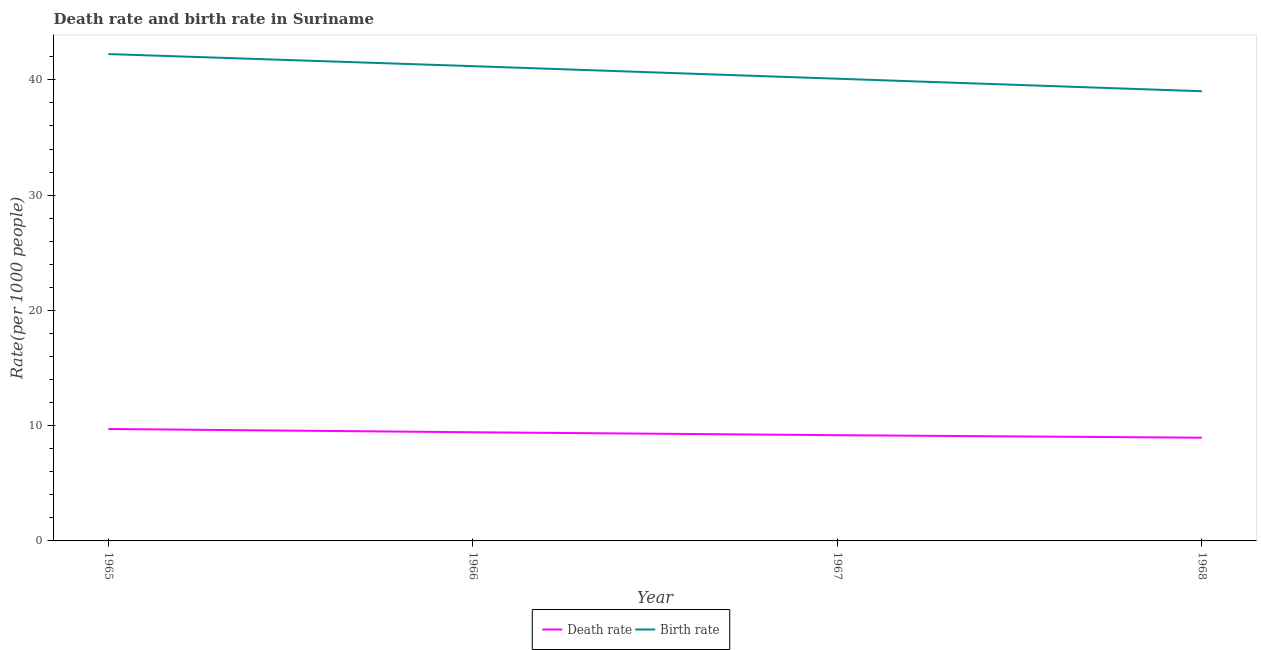How many different coloured lines are there?
Make the answer very short. 2. Does the line corresponding to birth rate intersect with the line corresponding to death rate?
Make the answer very short. No. Is the number of lines equal to the number of legend labels?
Provide a succinct answer. Yes. What is the birth rate in 1967?
Offer a terse response. 40.1. Across all years, what is the maximum death rate?
Your answer should be compact. 9.71. Across all years, what is the minimum birth rate?
Provide a succinct answer. 39.01. In which year was the birth rate maximum?
Offer a terse response. 1965. In which year was the birth rate minimum?
Give a very brief answer. 1968. What is the total death rate in the graph?
Offer a very short reply. 37.27. What is the difference between the death rate in 1965 and that in 1968?
Offer a very short reply. 0.76. What is the difference between the birth rate in 1966 and the death rate in 1965?
Give a very brief answer. 31.48. What is the average birth rate per year?
Your response must be concise. 40.64. In the year 1968, what is the difference between the birth rate and death rate?
Make the answer very short. 30.06. In how many years, is the death rate greater than 26?
Provide a short and direct response. 0. What is the ratio of the death rate in 1967 to that in 1968?
Keep it short and to the point. 1.02. Is the birth rate in 1965 less than that in 1967?
Offer a very short reply. No. What is the difference between the highest and the second highest birth rate?
Your answer should be very brief. 1.05. What is the difference between the highest and the lowest death rate?
Ensure brevity in your answer.  0.76. Is the birth rate strictly less than the death rate over the years?
Your response must be concise. No. Does the graph contain grids?
Your answer should be compact. No. How many legend labels are there?
Your response must be concise. 2. How are the legend labels stacked?
Your response must be concise. Horizontal. What is the title of the graph?
Give a very brief answer. Death rate and birth rate in Suriname. What is the label or title of the Y-axis?
Offer a very short reply. Rate(per 1000 people). What is the Rate(per 1000 people) of Death rate in 1965?
Give a very brief answer. 9.71. What is the Rate(per 1000 people) in Birth rate in 1965?
Your answer should be very brief. 42.24. What is the Rate(per 1000 people) in Death rate in 1966?
Your answer should be very brief. 9.43. What is the Rate(per 1000 people) of Birth rate in 1966?
Provide a short and direct response. 41.19. What is the Rate(per 1000 people) of Death rate in 1967?
Offer a terse response. 9.17. What is the Rate(per 1000 people) of Birth rate in 1967?
Make the answer very short. 40.1. What is the Rate(per 1000 people) of Death rate in 1968?
Offer a very short reply. 8.96. What is the Rate(per 1000 people) of Birth rate in 1968?
Make the answer very short. 39.01. Across all years, what is the maximum Rate(per 1000 people) of Death rate?
Keep it short and to the point. 9.71. Across all years, what is the maximum Rate(per 1000 people) in Birth rate?
Keep it short and to the point. 42.24. Across all years, what is the minimum Rate(per 1000 people) of Death rate?
Offer a terse response. 8.96. Across all years, what is the minimum Rate(per 1000 people) in Birth rate?
Your answer should be very brief. 39.01. What is the total Rate(per 1000 people) of Death rate in the graph?
Ensure brevity in your answer.  37.27. What is the total Rate(per 1000 people) of Birth rate in the graph?
Offer a terse response. 162.54. What is the difference between the Rate(per 1000 people) of Death rate in 1965 and that in 1966?
Offer a terse response. 0.28. What is the difference between the Rate(per 1000 people) of Birth rate in 1965 and that in 1966?
Your answer should be compact. 1.05. What is the difference between the Rate(per 1000 people) of Death rate in 1965 and that in 1967?
Make the answer very short. 0.54. What is the difference between the Rate(per 1000 people) in Birth rate in 1965 and that in 1967?
Give a very brief answer. 2.14. What is the difference between the Rate(per 1000 people) of Death rate in 1965 and that in 1968?
Provide a short and direct response. 0.76. What is the difference between the Rate(per 1000 people) of Birth rate in 1965 and that in 1968?
Give a very brief answer. 3.23. What is the difference between the Rate(per 1000 people) of Death rate in 1966 and that in 1967?
Your answer should be compact. 0.25. What is the difference between the Rate(per 1000 people) in Birth rate in 1966 and that in 1967?
Your answer should be compact. 1.09. What is the difference between the Rate(per 1000 people) in Death rate in 1966 and that in 1968?
Provide a short and direct response. 0.47. What is the difference between the Rate(per 1000 people) in Birth rate in 1966 and that in 1968?
Offer a very short reply. 2.18. What is the difference between the Rate(per 1000 people) of Death rate in 1967 and that in 1968?
Provide a short and direct response. 0.22. What is the difference between the Rate(per 1000 people) of Birth rate in 1967 and that in 1968?
Provide a short and direct response. 1.09. What is the difference between the Rate(per 1000 people) in Death rate in 1965 and the Rate(per 1000 people) in Birth rate in 1966?
Offer a terse response. -31.48. What is the difference between the Rate(per 1000 people) in Death rate in 1965 and the Rate(per 1000 people) in Birth rate in 1967?
Make the answer very short. -30.39. What is the difference between the Rate(per 1000 people) of Death rate in 1965 and the Rate(per 1000 people) of Birth rate in 1968?
Give a very brief answer. -29.3. What is the difference between the Rate(per 1000 people) in Death rate in 1966 and the Rate(per 1000 people) in Birth rate in 1967?
Your answer should be very brief. -30.67. What is the difference between the Rate(per 1000 people) in Death rate in 1966 and the Rate(per 1000 people) in Birth rate in 1968?
Your answer should be compact. -29.59. What is the difference between the Rate(per 1000 people) of Death rate in 1967 and the Rate(per 1000 people) of Birth rate in 1968?
Your answer should be compact. -29.84. What is the average Rate(per 1000 people) of Death rate per year?
Give a very brief answer. 9.32. What is the average Rate(per 1000 people) in Birth rate per year?
Your response must be concise. 40.64. In the year 1965, what is the difference between the Rate(per 1000 people) in Death rate and Rate(per 1000 people) in Birth rate?
Provide a succinct answer. -32.53. In the year 1966, what is the difference between the Rate(per 1000 people) of Death rate and Rate(per 1000 people) of Birth rate?
Your answer should be compact. -31.76. In the year 1967, what is the difference between the Rate(per 1000 people) in Death rate and Rate(per 1000 people) in Birth rate?
Offer a very short reply. -30.93. In the year 1968, what is the difference between the Rate(per 1000 people) of Death rate and Rate(per 1000 people) of Birth rate?
Provide a short and direct response. -30.06. What is the ratio of the Rate(per 1000 people) of Death rate in 1965 to that in 1966?
Provide a short and direct response. 1.03. What is the ratio of the Rate(per 1000 people) in Birth rate in 1965 to that in 1966?
Your answer should be compact. 1.03. What is the ratio of the Rate(per 1000 people) in Death rate in 1965 to that in 1967?
Your answer should be compact. 1.06. What is the ratio of the Rate(per 1000 people) in Birth rate in 1965 to that in 1967?
Offer a terse response. 1.05. What is the ratio of the Rate(per 1000 people) in Death rate in 1965 to that in 1968?
Keep it short and to the point. 1.08. What is the ratio of the Rate(per 1000 people) of Birth rate in 1965 to that in 1968?
Your answer should be very brief. 1.08. What is the ratio of the Rate(per 1000 people) of Death rate in 1966 to that in 1967?
Provide a succinct answer. 1.03. What is the ratio of the Rate(per 1000 people) in Birth rate in 1966 to that in 1967?
Provide a short and direct response. 1.03. What is the ratio of the Rate(per 1000 people) in Death rate in 1966 to that in 1968?
Ensure brevity in your answer.  1.05. What is the ratio of the Rate(per 1000 people) in Birth rate in 1966 to that in 1968?
Offer a very short reply. 1.06. What is the ratio of the Rate(per 1000 people) of Death rate in 1967 to that in 1968?
Offer a very short reply. 1.02. What is the ratio of the Rate(per 1000 people) in Birth rate in 1967 to that in 1968?
Provide a succinct answer. 1.03. What is the difference between the highest and the second highest Rate(per 1000 people) in Death rate?
Make the answer very short. 0.28. What is the difference between the highest and the second highest Rate(per 1000 people) in Birth rate?
Provide a succinct answer. 1.05. What is the difference between the highest and the lowest Rate(per 1000 people) in Death rate?
Your answer should be compact. 0.76. What is the difference between the highest and the lowest Rate(per 1000 people) of Birth rate?
Provide a succinct answer. 3.23. 